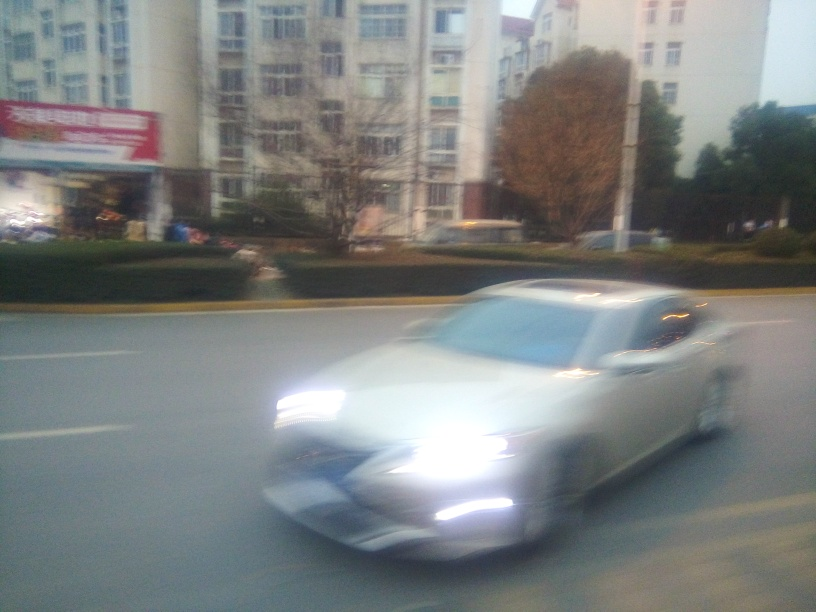Can you guess why the image might be blurry? The blur is most likely due to a combination of the car's rapid movement and a slower shutter speed on the camera. It's a common photographic issue when trying to capture moving objects, especially in lower lighting conditions where the camera may not be able to compensate for the speed of moving subjects. How could this blurriness be prevented in future photos? To reduce blurriness, one could increase the camera's shutter speed to freeze the motion, use a tripod to stabilize the camera, or activate built-in image stabilization features if available. Additionally, increasing the ISO or opening the aperture can help to achieve a clearer shot in low-light conditions. 